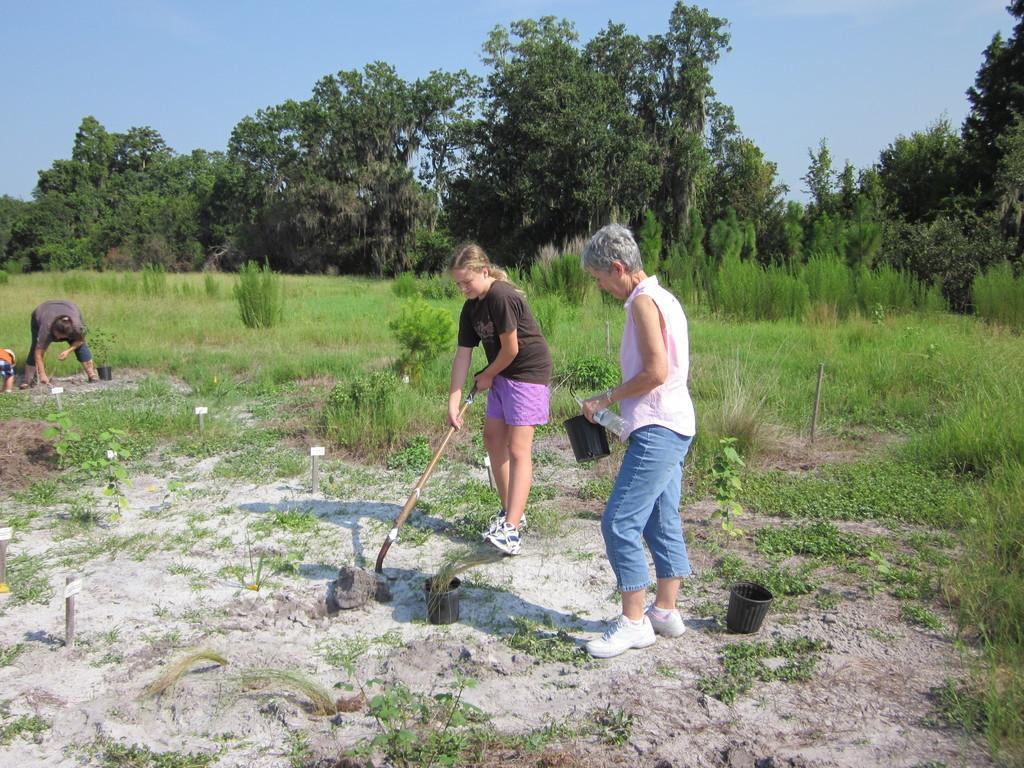Could you give a brief overview of what you see in this image? In the center of a picture there are women standing. The girl in black dress is holding the spade. The woman in pink dress is holding water bottle and bucket. On the right there are trees, grass. In the background there are trees and grass. On the left there is a kid and a man planting trees. 